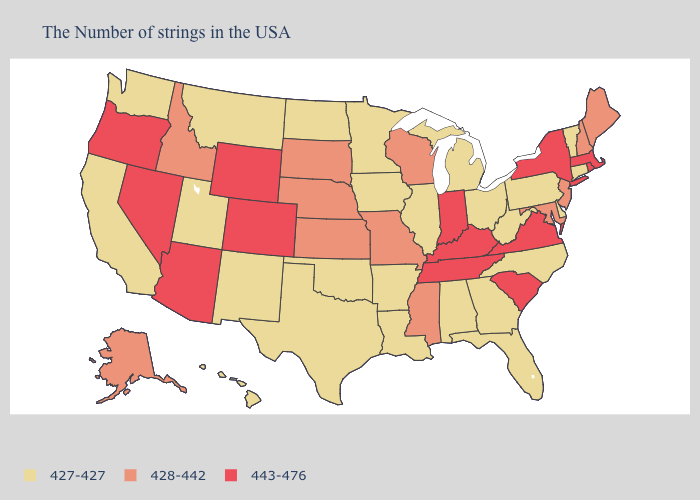What is the lowest value in the West?
Be succinct. 427-427. What is the lowest value in the West?
Be succinct. 427-427. What is the value of South Carolina?
Give a very brief answer. 443-476. What is the value of South Carolina?
Concise answer only. 443-476. What is the value of Pennsylvania?
Short answer required. 427-427. Among the states that border Arkansas , which have the lowest value?
Answer briefly. Louisiana, Oklahoma, Texas. Does the first symbol in the legend represent the smallest category?
Concise answer only. Yes. Among the states that border Nebraska , which have the lowest value?
Concise answer only. Iowa. Name the states that have a value in the range 427-427?
Be succinct. Vermont, Connecticut, Delaware, Pennsylvania, North Carolina, West Virginia, Ohio, Florida, Georgia, Michigan, Alabama, Illinois, Louisiana, Arkansas, Minnesota, Iowa, Oklahoma, Texas, North Dakota, New Mexico, Utah, Montana, California, Washington, Hawaii. What is the value of Massachusetts?
Write a very short answer. 443-476. Which states have the highest value in the USA?
Be succinct. Massachusetts, Rhode Island, New York, Virginia, South Carolina, Kentucky, Indiana, Tennessee, Wyoming, Colorado, Arizona, Nevada, Oregon. Name the states that have a value in the range 443-476?
Concise answer only. Massachusetts, Rhode Island, New York, Virginia, South Carolina, Kentucky, Indiana, Tennessee, Wyoming, Colorado, Arizona, Nevada, Oregon. What is the lowest value in the West?
Concise answer only. 427-427. What is the value of Delaware?
Keep it brief. 427-427. 